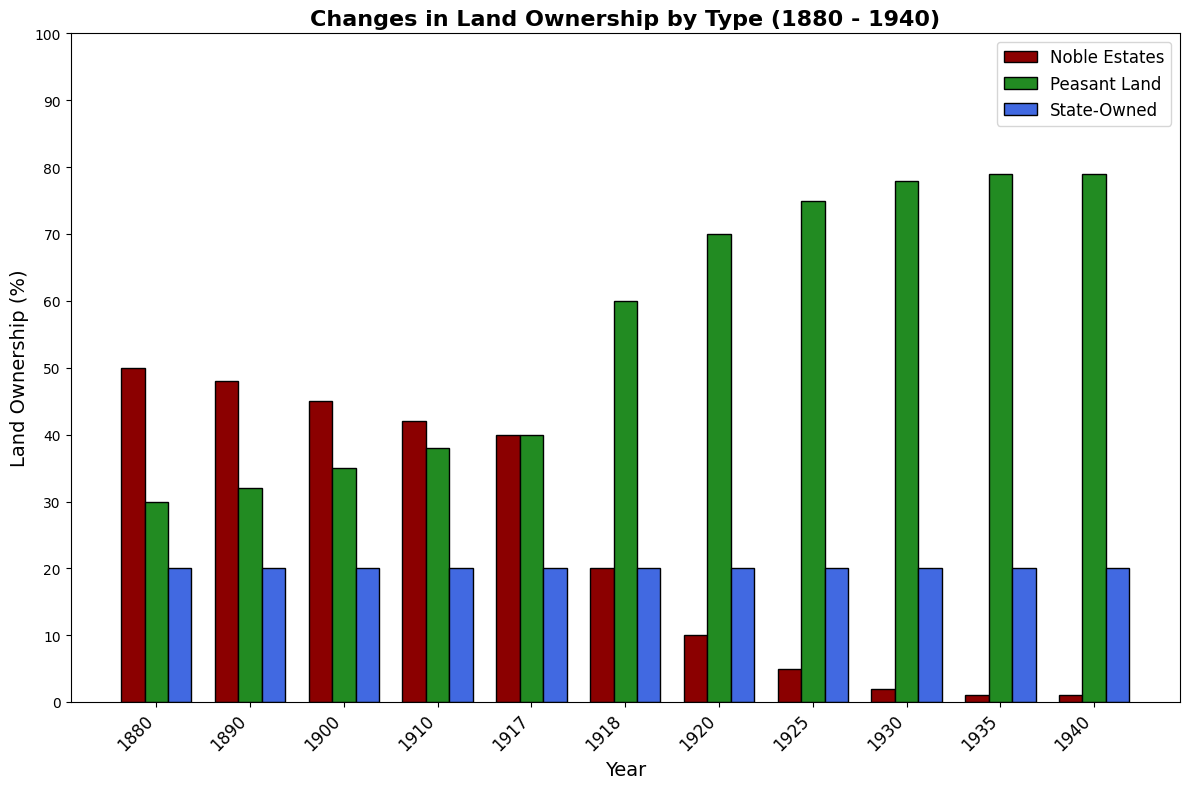Which type of land ownership had the highest percentage in 1930? In 1930, the height of the bars indicates Peasant Land had the highest percentage compared to Noble Estates and State-Owned land. By looking at the heights, Peasant Land is visibly the tallest.
Answer: Peasant Land By how much did the percentage of Noble Estates decrease from 1880 to 1918? In 1880, Noble Estates are at 50%. By 1918, they are at 20%. The decrease is 50% - 20% = 30%.
Answer: 30% How did the percentage of Peasant Land change between 1917 and 1925? In 1917, Peasant Land is at 40%. By 1925, it is at 75%. The change is 75% - 40% = 35%.
Answer: 35% What is the combined percentage of Noble Estates and State-Owned land in 1880? The Noble Estates in 1880 are at 50%, and State-Owned land is 20%. Summing these up gives 50% + 20% = 70%.
Answer: 70% Which type of land remained constant throughout the period 1880 to 1940? By visually inspecting the chart, State-Owned land remains at 20% from 1880 to 1940, unchanged across all years.
Answer: State-Owned In which decade did Noble Estates see the most significant drop in percentage? The most significant drop occurred between 1917 and 1918, where it went from 40% to 20%, a decrease of 20%.
Answer: 1910s What is the percentage of Peasant Land in 1940? By looking at the chart, in 1940, the height of the bar for Peasant Land touches 79%.
Answer: 79% Compare the Noble Estates in 1880 and 1940. What is the ratio of their percentages? In 1880, Noble Estates were at 50%, and in 1940, they were at 1%. The ratio is 50:1.
Answer: 50:1 Identify the year when Peasant Land first exceeded the percentage of Noble Estates? By checking the chart, Peasant Land exceeded Noble Estates first in 1917; both were equal at 40% before Noble Estates decreased further.
Answer: 1917 What was the total percentage of Peasant Land, Noble Estates, and State-Owned land in 1920? Adding the values in 1920 for all lands: Peasant Land (70%) + Noble Estates (10%) + State-Owned (20%) = 100%.
Answer: 100% 